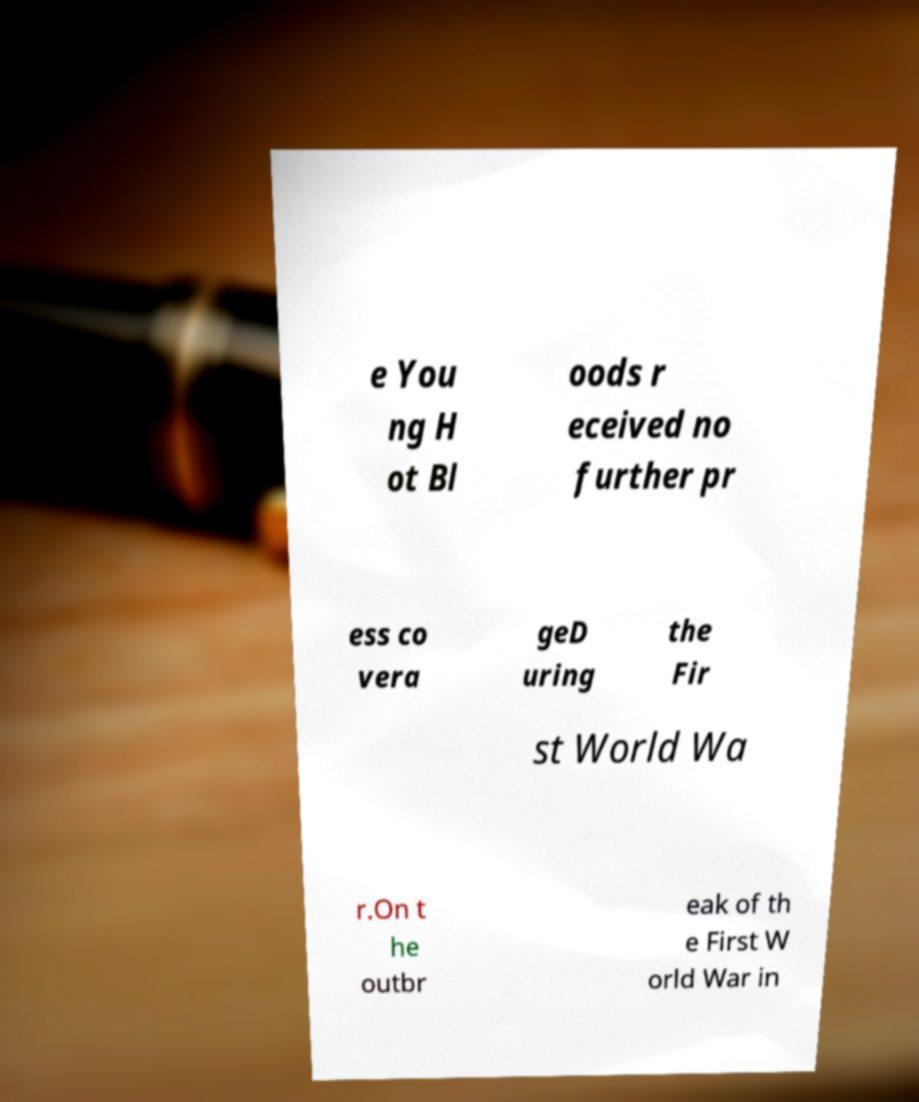For documentation purposes, I need the text within this image transcribed. Could you provide that? e You ng H ot Bl oods r eceived no further pr ess co vera geD uring the Fir st World Wa r.On t he outbr eak of th e First W orld War in 